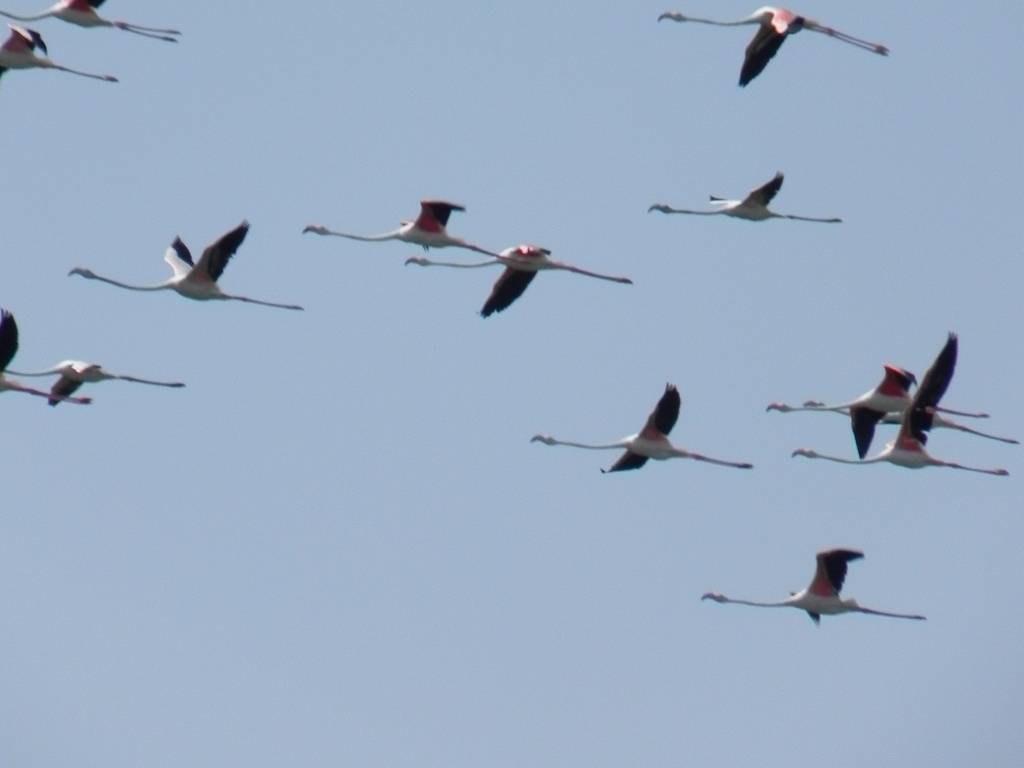Are flamingos always pink, and how do they get their color? Flamingos are not born pink; they're born with grey feathers. They acquire their pink color from carotenoid pigments in their diet of algae, brine shrimp, and other plankton. The intensity of the pink hue varies with diet and can range from pale pink to bright red. Do their diet and habitat have challenges? Yes, the flamingos' habitat is sensitive to environmental changes like changes in water level and salinity, which can affect the availability of their food sources. Pollution, habitat loss, and disturbances by humans are also threats to their habitat and food supply, leading to conservation concerns for these birds. 